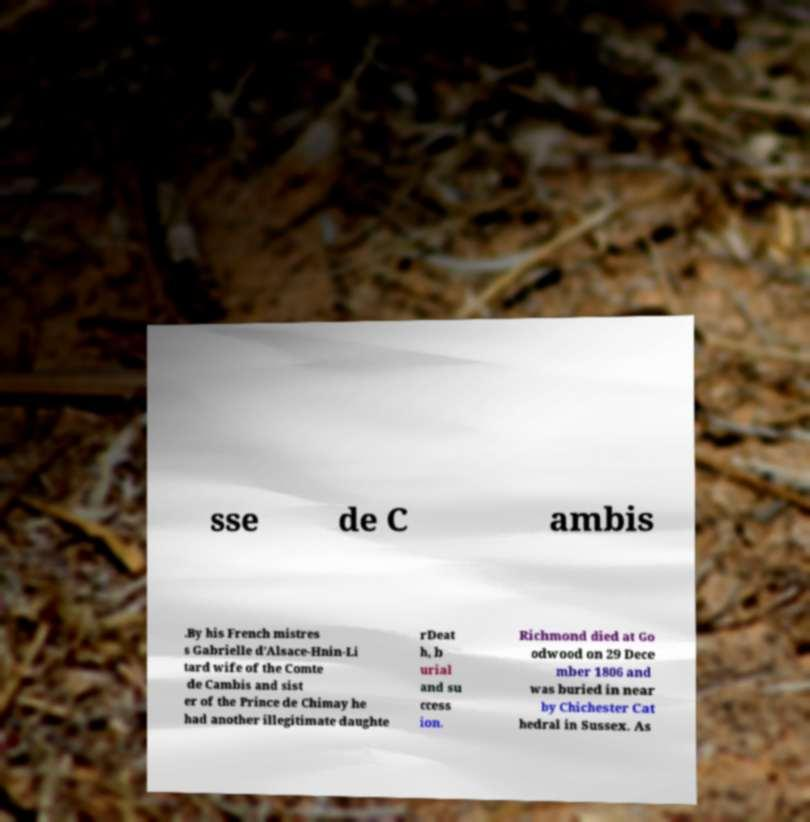Please read and relay the text visible in this image. What does it say? sse de C ambis .By his French mistres s Gabrielle d'Alsace-Hnin-Li tard wife of the Comte de Cambis and sist er of the Prince de Chimay he had another illegitimate daughte rDeat h, b urial and su ccess ion. Richmond died at Go odwood on 29 Dece mber 1806 and was buried in near by Chichester Cat hedral in Sussex. As 